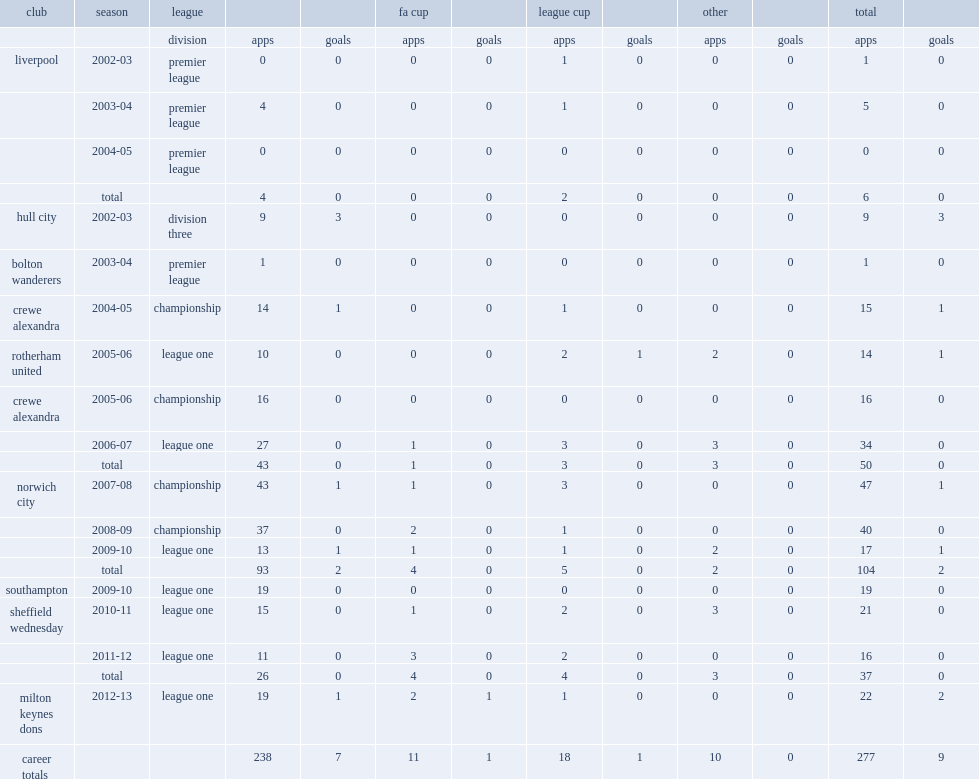After the 2011-12 football league one season with sheffield wednesday, how many times have jon otsemobor played for the club in the league since he joined in 2010? 26.0. 